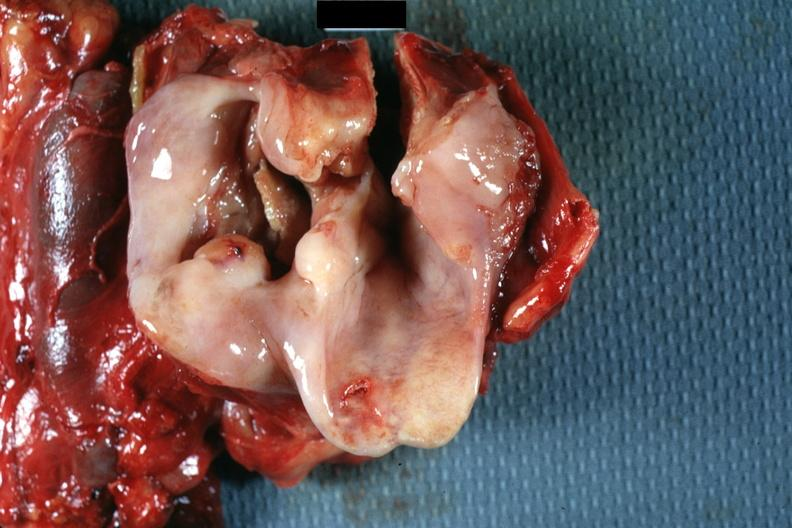s hypopharynx present?
Answer the question using a single word or phrase. Yes 